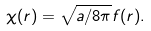Convert formula to latex. <formula><loc_0><loc_0><loc_500><loc_500>\chi ( { r } ) = \sqrt { a / 8 \pi } f ( { r } ) .</formula> 